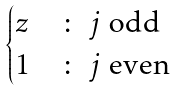<formula> <loc_0><loc_0><loc_500><loc_500>\begin{cases} z & \colon \text { $j$ odd} \\ 1 & \colon \text { $j$ even } \end{cases}</formula> 